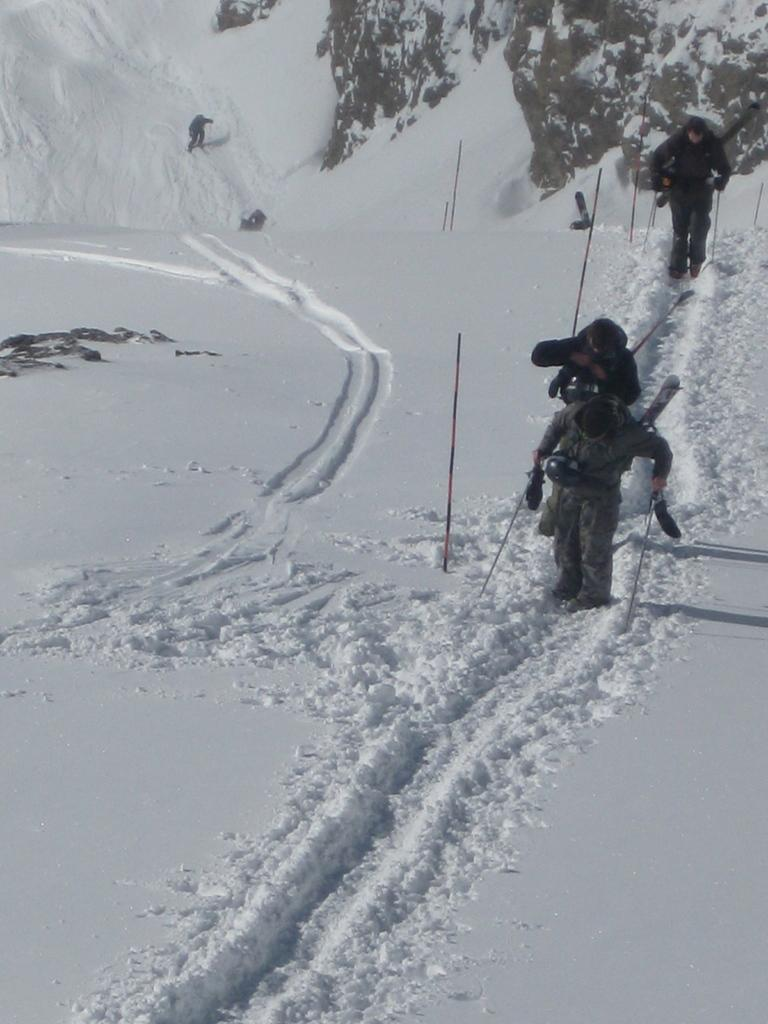What is happening in the image? There is a group of people in the image, and they are walking in the snow. What are the people holding while walking in the snow? The people are holding sticks. What type of pleasure can be seen on the toad's face in the image? There is no toad present in the image, and therefore no facial expression to analyze. 